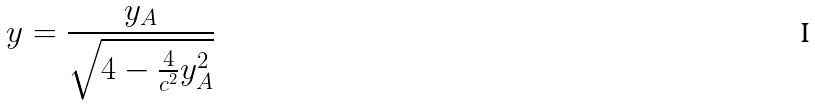<formula> <loc_0><loc_0><loc_500><loc_500>y = \frac { y _ { A } } { \sqrt { 4 - \frac { 4 } { c ^ { 2 } } y _ { A } ^ { 2 } } }</formula> 